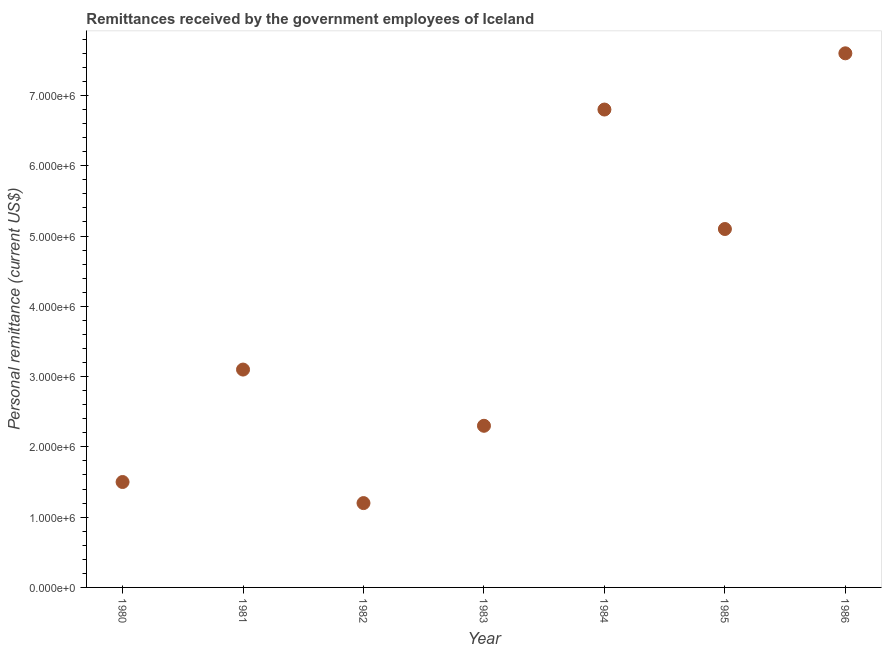What is the personal remittances in 1986?
Offer a terse response. 7.60e+06. Across all years, what is the maximum personal remittances?
Your answer should be very brief. 7.60e+06. Across all years, what is the minimum personal remittances?
Make the answer very short. 1.20e+06. In which year was the personal remittances maximum?
Provide a short and direct response. 1986. What is the sum of the personal remittances?
Provide a succinct answer. 2.76e+07. What is the difference between the personal remittances in 1981 and 1984?
Your response must be concise. -3.70e+06. What is the average personal remittances per year?
Offer a very short reply. 3.94e+06. What is the median personal remittances?
Your response must be concise. 3.10e+06. What is the ratio of the personal remittances in 1981 to that in 1985?
Make the answer very short. 0.61. Is the difference between the personal remittances in 1984 and 1985 greater than the difference between any two years?
Offer a very short reply. No. What is the difference between the highest and the second highest personal remittances?
Offer a terse response. 8.00e+05. What is the difference between the highest and the lowest personal remittances?
Your answer should be very brief. 6.40e+06. In how many years, is the personal remittances greater than the average personal remittances taken over all years?
Offer a very short reply. 3. Does the personal remittances monotonically increase over the years?
Ensure brevity in your answer.  No. How many years are there in the graph?
Provide a succinct answer. 7. What is the difference between two consecutive major ticks on the Y-axis?
Keep it short and to the point. 1.00e+06. Does the graph contain grids?
Provide a succinct answer. No. What is the title of the graph?
Ensure brevity in your answer.  Remittances received by the government employees of Iceland. What is the label or title of the Y-axis?
Make the answer very short. Personal remittance (current US$). What is the Personal remittance (current US$) in 1980?
Your answer should be very brief. 1.50e+06. What is the Personal remittance (current US$) in 1981?
Your answer should be very brief. 3.10e+06. What is the Personal remittance (current US$) in 1982?
Provide a short and direct response. 1.20e+06. What is the Personal remittance (current US$) in 1983?
Provide a succinct answer. 2.30e+06. What is the Personal remittance (current US$) in 1984?
Provide a short and direct response. 6.80e+06. What is the Personal remittance (current US$) in 1985?
Offer a terse response. 5.10e+06. What is the Personal remittance (current US$) in 1986?
Make the answer very short. 7.60e+06. What is the difference between the Personal remittance (current US$) in 1980 and 1981?
Ensure brevity in your answer.  -1.60e+06. What is the difference between the Personal remittance (current US$) in 1980 and 1982?
Your answer should be compact. 3.00e+05. What is the difference between the Personal remittance (current US$) in 1980 and 1983?
Make the answer very short. -8.00e+05. What is the difference between the Personal remittance (current US$) in 1980 and 1984?
Offer a very short reply. -5.30e+06. What is the difference between the Personal remittance (current US$) in 1980 and 1985?
Provide a short and direct response. -3.60e+06. What is the difference between the Personal remittance (current US$) in 1980 and 1986?
Provide a short and direct response. -6.10e+06. What is the difference between the Personal remittance (current US$) in 1981 and 1982?
Ensure brevity in your answer.  1.90e+06. What is the difference between the Personal remittance (current US$) in 1981 and 1983?
Provide a succinct answer. 8.00e+05. What is the difference between the Personal remittance (current US$) in 1981 and 1984?
Offer a very short reply. -3.70e+06. What is the difference between the Personal remittance (current US$) in 1981 and 1986?
Your answer should be compact. -4.50e+06. What is the difference between the Personal remittance (current US$) in 1982 and 1983?
Provide a succinct answer. -1.10e+06. What is the difference between the Personal remittance (current US$) in 1982 and 1984?
Make the answer very short. -5.60e+06. What is the difference between the Personal remittance (current US$) in 1982 and 1985?
Give a very brief answer. -3.90e+06. What is the difference between the Personal remittance (current US$) in 1982 and 1986?
Offer a terse response. -6.40e+06. What is the difference between the Personal remittance (current US$) in 1983 and 1984?
Provide a short and direct response. -4.50e+06. What is the difference between the Personal remittance (current US$) in 1983 and 1985?
Make the answer very short. -2.80e+06. What is the difference between the Personal remittance (current US$) in 1983 and 1986?
Your response must be concise. -5.30e+06. What is the difference between the Personal remittance (current US$) in 1984 and 1985?
Give a very brief answer. 1.70e+06. What is the difference between the Personal remittance (current US$) in 1984 and 1986?
Offer a terse response. -8.00e+05. What is the difference between the Personal remittance (current US$) in 1985 and 1986?
Provide a short and direct response. -2.50e+06. What is the ratio of the Personal remittance (current US$) in 1980 to that in 1981?
Offer a terse response. 0.48. What is the ratio of the Personal remittance (current US$) in 1980 to that in 1983?
Your answer should be compact. 0.65. What is the ratio of the Personal remittance (current US$) in 1980 to that in 1984?
Your answer should be compact. 0.22. What is the ratio of the Personal remittance (current US$) in 1980 to that in 1985?
Your answer should be compact. 0.29. What is the ratio of the Personal remittance (current US$) in 1980 to that in 1986?
Offer a very short reply. 0.2. What is the ratio of the Personal remittance (current US$) in 1981 to that in 1982?
Offer a terse response. 2.58. What is the ratio of the Personal remittance (current US$) in 1981 to that in 1983?
Make the answer very short. 1.35. What is the ratio of the Personal remittance (current US$) in 1981 to that in 1984?
Your response must be concise. 0.46. What is the ratio of the Personal remittance (current US$) in 1981 to that in 1985?
Your response must be concise. 0.61. What is the ratio of the Personal remittance (current US$) in 1981 to that in 1986?
Offer a very short reply. 0.41. What is the ratio of the Personal remittance (current US$) in 1982 to that in 1983?
Your answer should be very brief. 0.52. What is the ratio of the Personal remittance (current US$) in 1982 to that in 1984?
Keep it short and to the point. 0.18. What is the ratio of the Personal remittance (current US$) in 1982 to that in 1985?
Your response must be concise. 0.23. What is the ratio of the Personal remittance (current US$) in 1982 to that in 1986?
Your answer should be compact. 0.16. What is the ratio of the Personal remittance (current US$) in 1983 to that in 1984?
Provide a succinct answer. 0.34. What is the ratio of the Personal remittance (current US$) in 1983 to that in 1985?
Your answer should be compact. 0.45. What is the ratio of the Personal remittance (current US$) in 1983 to that in 1986?
Offer a very short reply. 0.3. What is the ratio of the Personal remittance (current US$) in 1984 to that in 1985?
Your answer should be very brief. 1.33. What is the ratio of the Personal remittance (current US$) in 1984 to that in 1986?
Make the answer very short. 0.9. What is the ratio of the Personal remittance (current US$) in 1985 to that in 1986?
Make the answer very short. 0.67. 